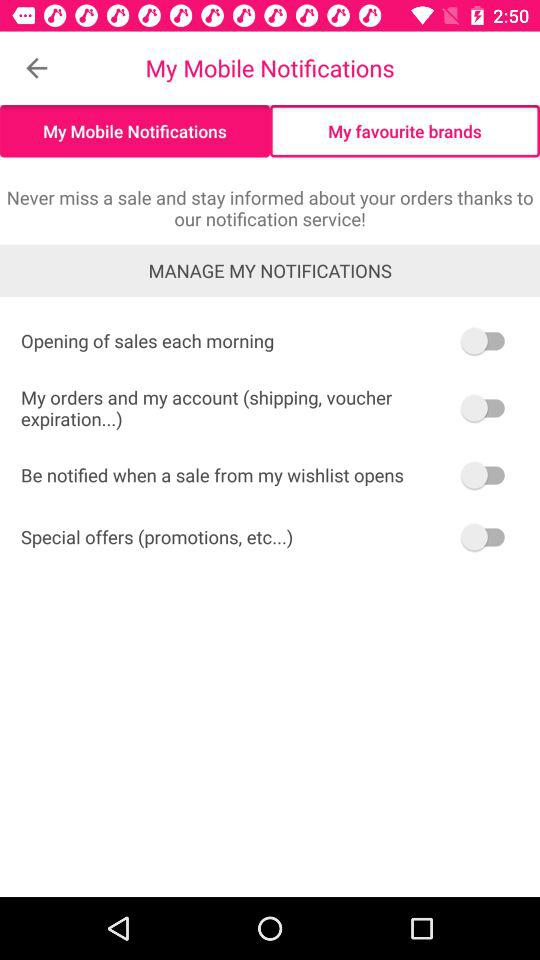How many switches are there?
Answer the question using a single word or phrase. 4 